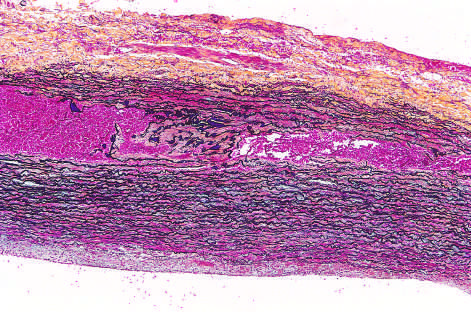re black aortic elastic layers, and red blood in this section, stained with movat stain?
Answer the question using a single word or phrase. Yes 